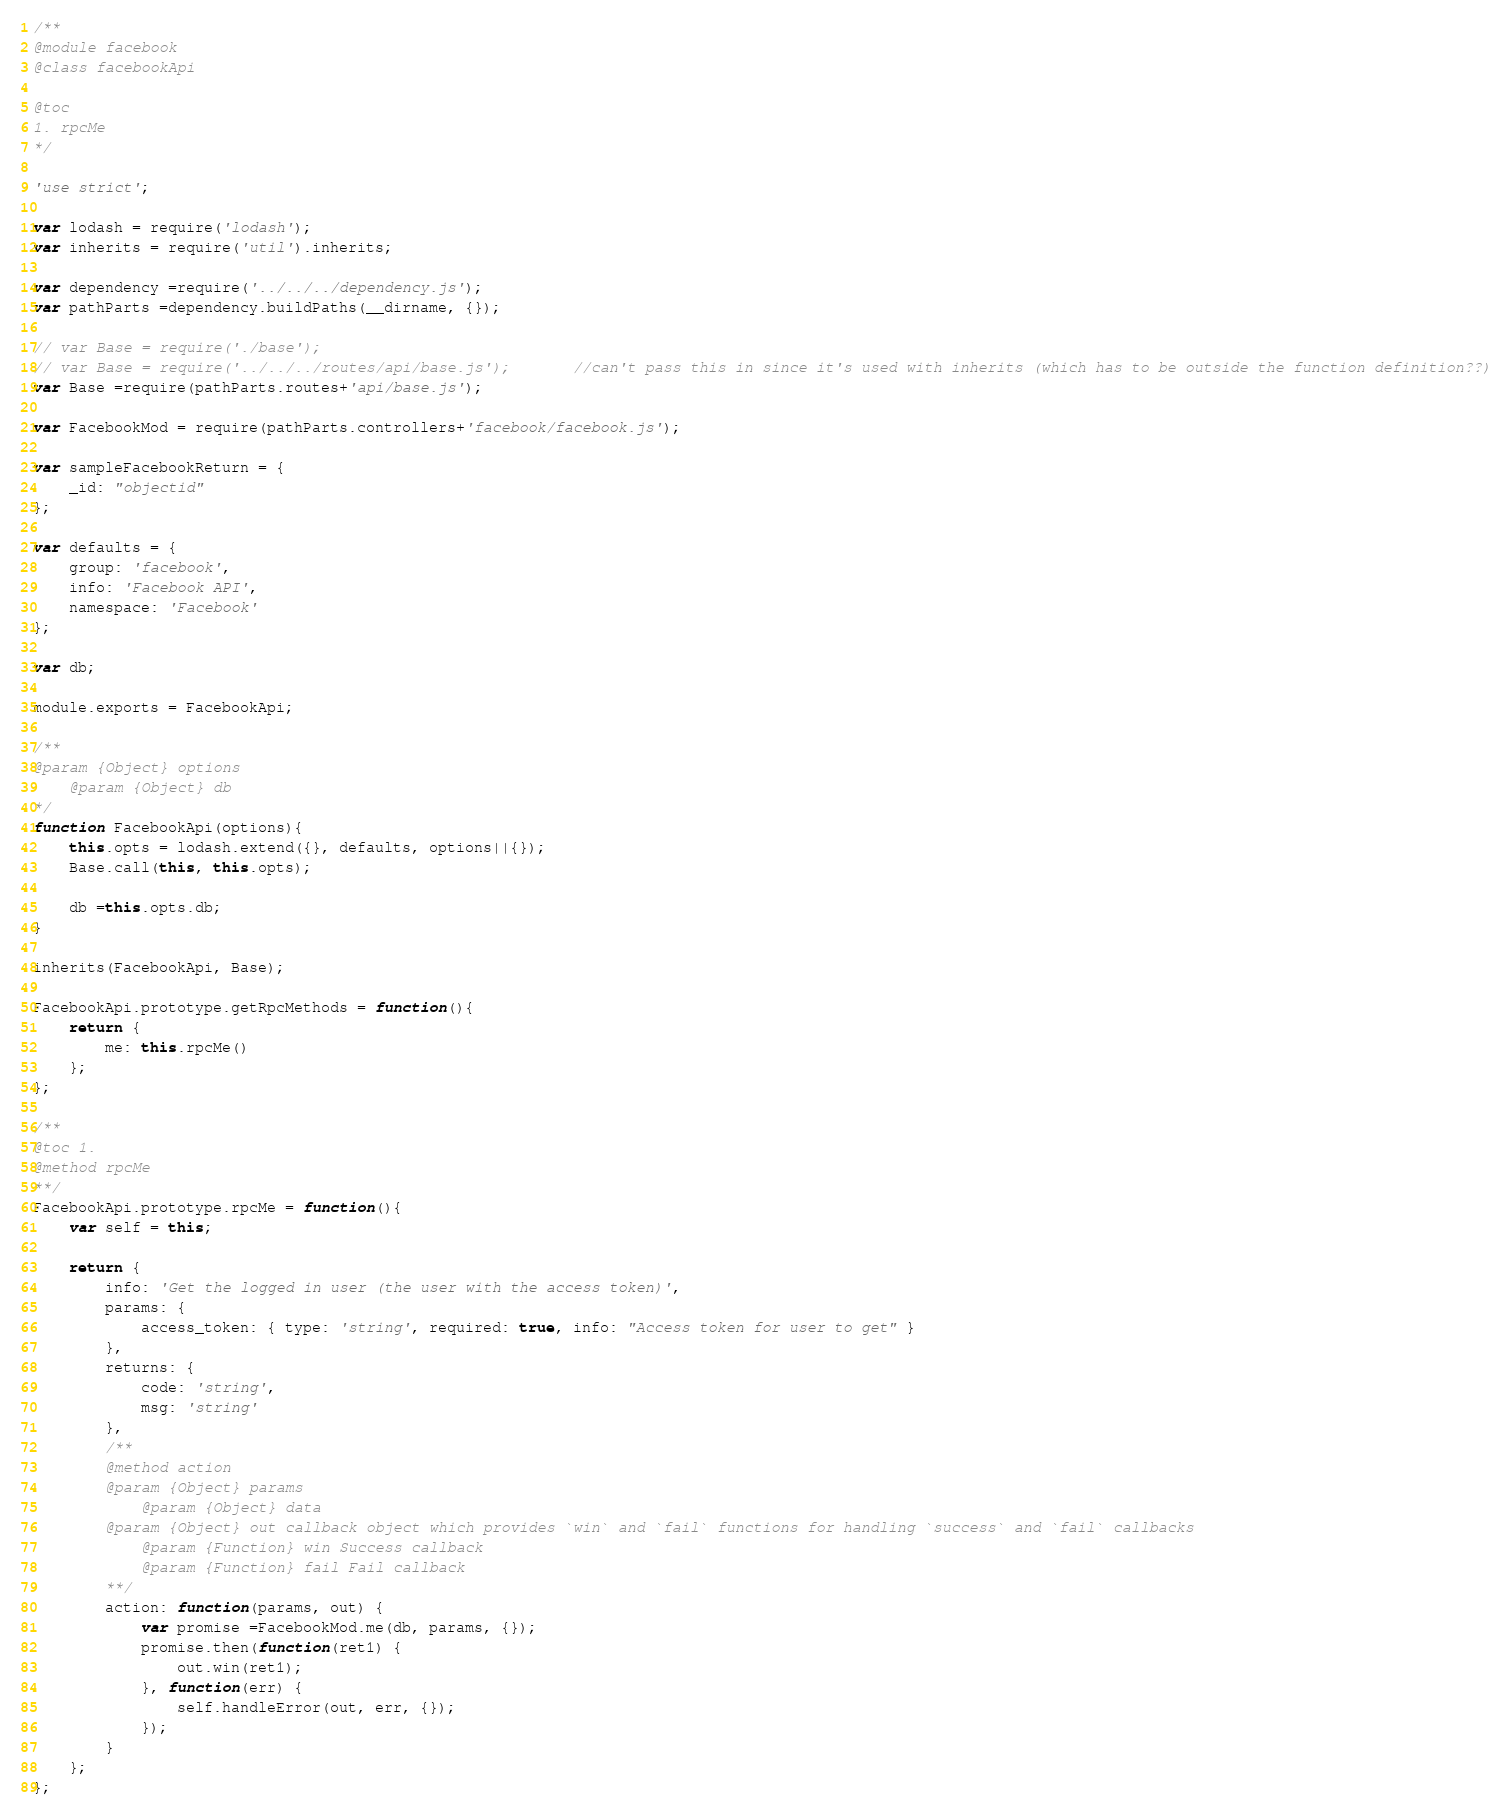Convert code to text. <code><loc_0><loc_0><loc_500><loc_500><_JavaScript_>/**
@module facebook
@class facebookApi

@toc
1. rpcMe
*/

'use strict';

var lodash = require('lodash');
var inherits = require('util').inherits;

var dependency =require('../../../dependency.js');
var pathParts =dependency.buildPaths(__dirname, {});

// var Base = require('./base');
// var Base = require('../../../routes/api/base.js');		//can't pass this in since it's used with inherits (which has to be outside the function definition??)
var Base =require(pathParts.routes+'api/base.js');

var FacebookMod = require(pathParts.controllers+'facebook/facebook.js');

var sampleFacebookReturn = {
	_id: "objectid"
};

var defaults = {
	group: 'facebook',
	info: 'Facebook API',
	namespace: 'Facebook'
};

var db;

module.exports = FacebookApi;

/**
@param {Object} options
	@param {Object} db
*/
function FacebookApi(options){
	this.opts = lodash.extend({}, defaults, options||{});
	Base.call(this, this.opts);
	
	db =this.opts.db;
}

inherits(FacebookApi, Base);

FacebookApi.prototype.getRpcMethods = function(){
	return {
		me: this.rpcMe()
	};
};

/**
@toc 1.
@method rpcMe
**/
FacebookApi.prototype.rpcMe = function(){
	var self = this;

	return {
		info: 'Get the logged in user (the user with the access token)',
		params: {
			access_token: { type: 'string', required: true, info: "Access token for user to get" }
		},
		returns: {
			code: 'string',
			msg: 'string'
		},
		/**
		@method action
		@param {Object} params
			@param {Object} data
		@param {Object} out callback object which provides `win` and `fail` functions for handling `success` and `fail` callbacks
			@param {Function} win Success callback
			@param {Function} fail Fail callback
		**/
		action: function(params, out) {
			var promise =FacebookMod.me(db, params, {});
			promise.then(function(ret1) {
				out.win(ret1);
			}, function(err) {
				self.handleError(out, err, {});
			});
		}
	};
};</code> 